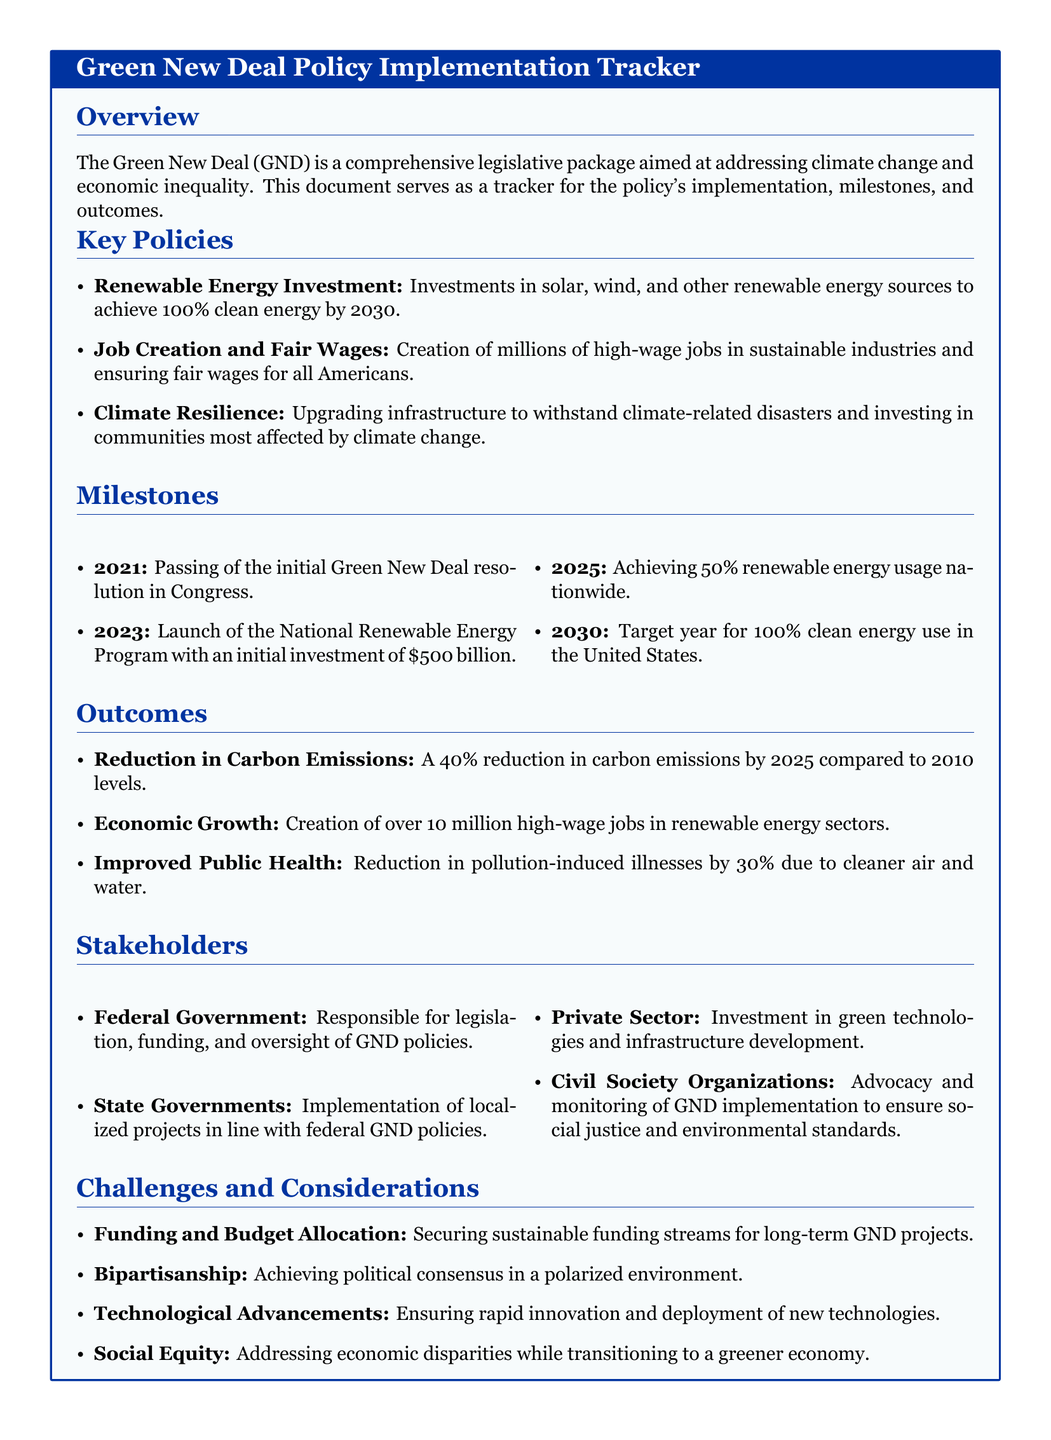What is the goal for renewable energy usage by 2030? The document states that the goal is to achieve 100% clean energy use in the United States by 2030.
Answer: 100% clean energy by 2030 How many high-wage jobs are expected to be created in renewable energy sectors? The document indicates that over 10 million high-wage jobs are expected to be created in renewable energy sectors.
Answer: Over 10 million What is the target year for achieving 50% renewable energy usage nationwide? The document states that the target year for achieving 50% renewable energy usage is 2025.
Answer: 2025 What type of organizations are responsible for advocacy and monitoring of GND implementation? The document specifies that civil society organizations are responsible for advocacy and monitoring.
Answer: Civil Society Organizations What percentage reduction in carbon emissions is targeted by 2025? The document specifies a 40% reduction in carbon emissions is targeted by 2025 compared to 2010 levels.
Answer: 40% reduction What is one of the major challenges mentioned in the document related to GND policies? The document lists several challenges, including funding and budget allocation as a major challenge.
Answer: Funding and budget allocation What was passed in Congress in 2021 related to the Green New Deal? The document states that the initial Green New Deal resolution was passed in Congress in 2021.
Answer: Initial Green New Deal resolution Which sector is expected to invest in green technologies as per the document? The document indicates that the private sector is expected to invest in green technologies.
Answer: Private Sector What is the first milestone for the Green New Deal implementation? The document states that the first milestone was the passing of the initial Green New Deal resolution in Congress in 2021.
Answer: Passing of the initial Green New Deal resolution 